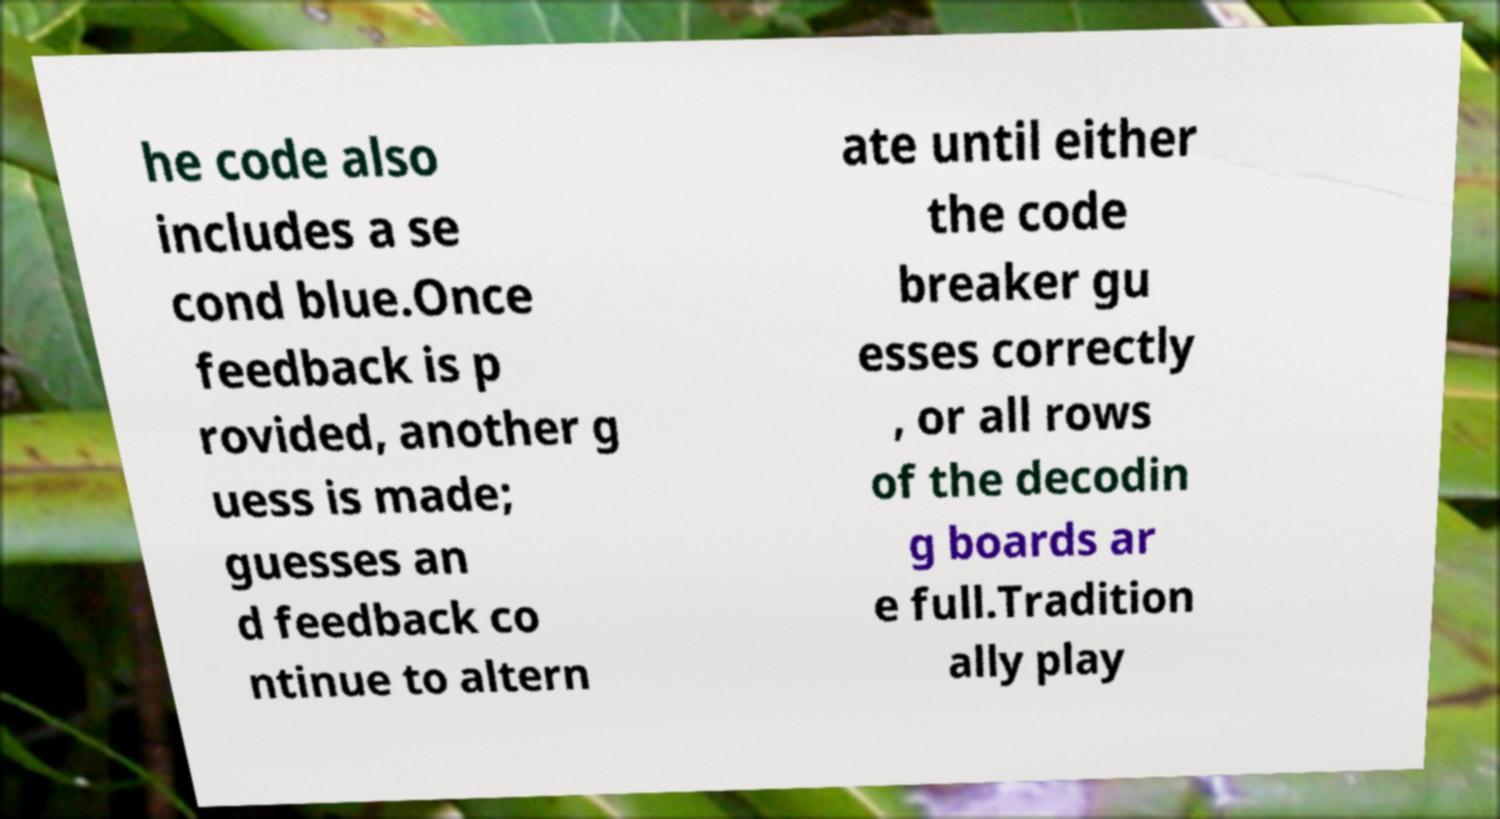Can you accurately transcribe the text from the provided image for me? he code also includes a se cond blue.Once feedback is p rovided, another g uess is made; guesses an d feedback co ntinue to altern ate until either the code breaker gu esses correctly , or all rows of the decodin g boards ar e full.Tradition ally play 